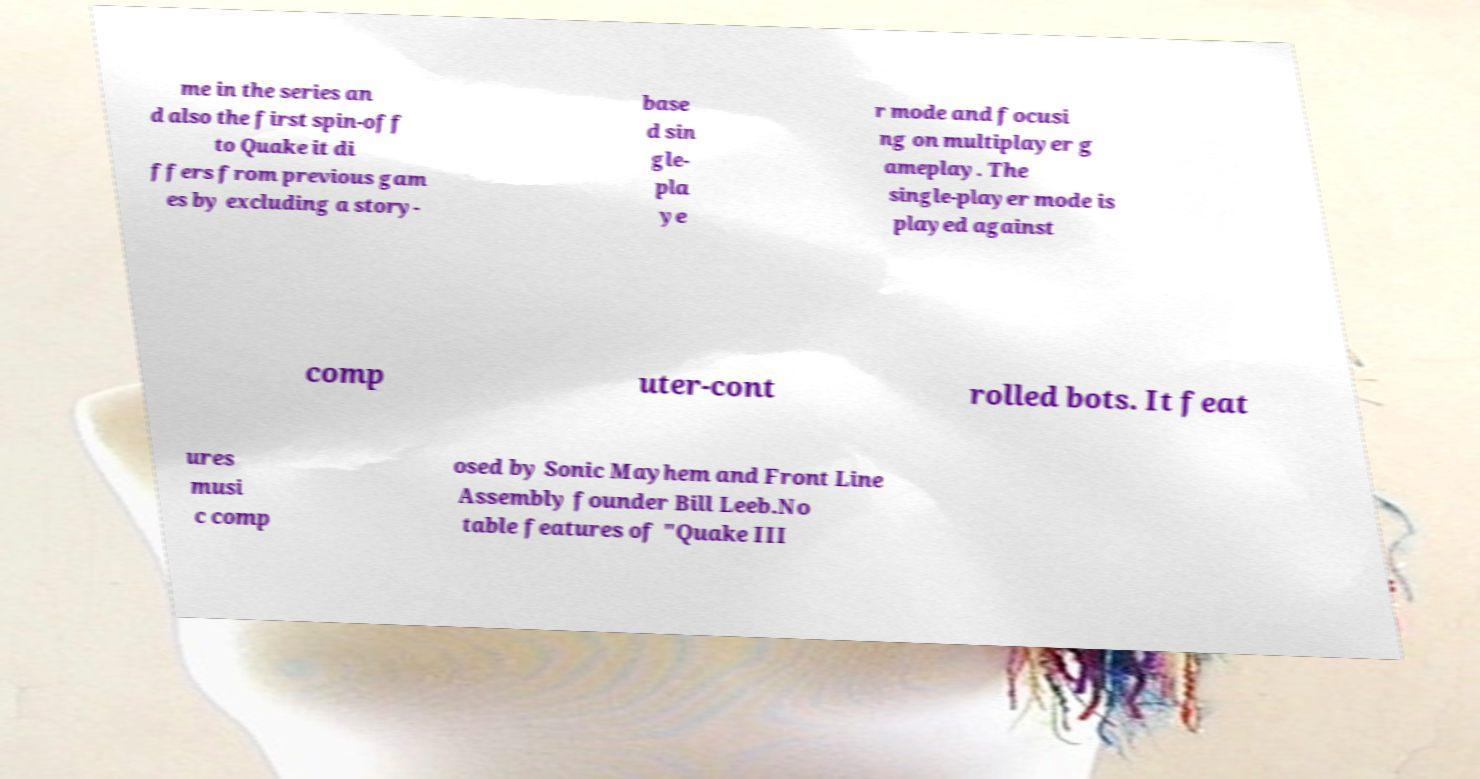There's text embedded in this image that I need extracted. Can you transcribe it verbatim? me in the series an d also the first spin-off to Quake it di ffers from previous gam es by excluding a story- base d sin gle- pla ye r mode and focusi ng on multiplayer g ameplay. The single-player mode is played against comp uter-cont rolled bots. It feat ures musi c comp osed by Sonic Mayhem and Front Line Assembly founder Bill Leeb.No table features of "Quake III 